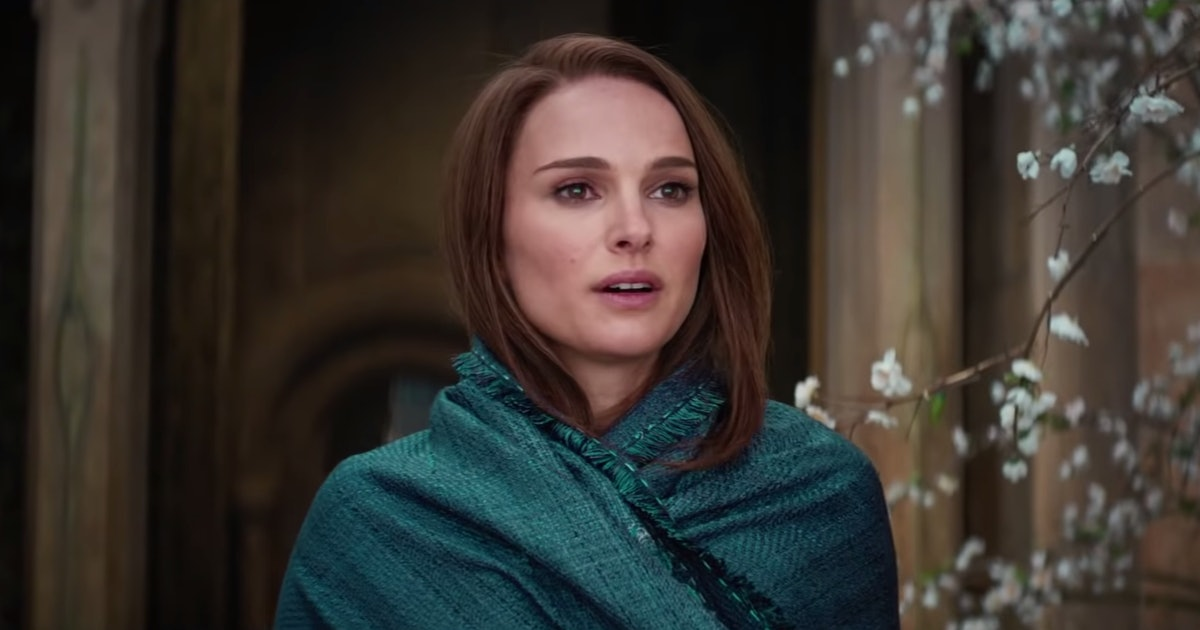What might she be thinking about in this serene environment? Given her thoughtful gaze and the serene backdrop, she could be reflecting on a personal journey or contemplating a significant decision. The quiet beauty of the surroundings, marked by the gentle flowering branch and the timeless stone architecture, suggests a moment of introspection, perhaps about her own place in the world or the complexities of life. 